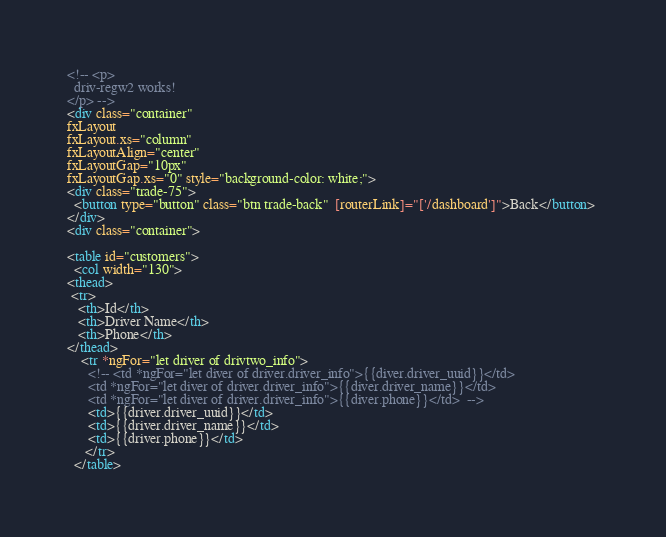<code> <loc_0><loc_0><loc_500><loc_500><_HTML_><!-- <p>
  driv-regw2 works!
</p> -->
<div class="container"
fxLayout
fxLayout.xs="column"
fxLayoutAlign="center"
fxLayoutGap="10px"
fxLayoutGap.xs="0" style="background-color: white;">
<div class="trade-75">
  <button type="button" class="btn trade-back"  [routerLink]="['/dashboard']">Back</button> 
</div>
<div class="container">
       
<table id="customers">
  <col width="130">
<thead>
 <tr>
   <th>Id</th>
   <th>Driver Name</th>
   <th>Phone</th>
</thead>
    <tr *ngFor="let driver of drivtwo_info">
      <!-- <td *ngFor="let diver of driver.driver_info">{{diver.driver_uuid}}</td>
      <td *ngFor="let diver of driver.driver_info">{{diver.driver_name}}</td>
      <td *ngFor="let diver of driver.driver_info">{{diver.phone}}</td>  -->
      <td>{{driver.driver_uuid}}</td> 
      <td>{{driver.driver_name}}</td>
      <td>{{driver.phone}}</td> 
     </tr>
  </table></code> 